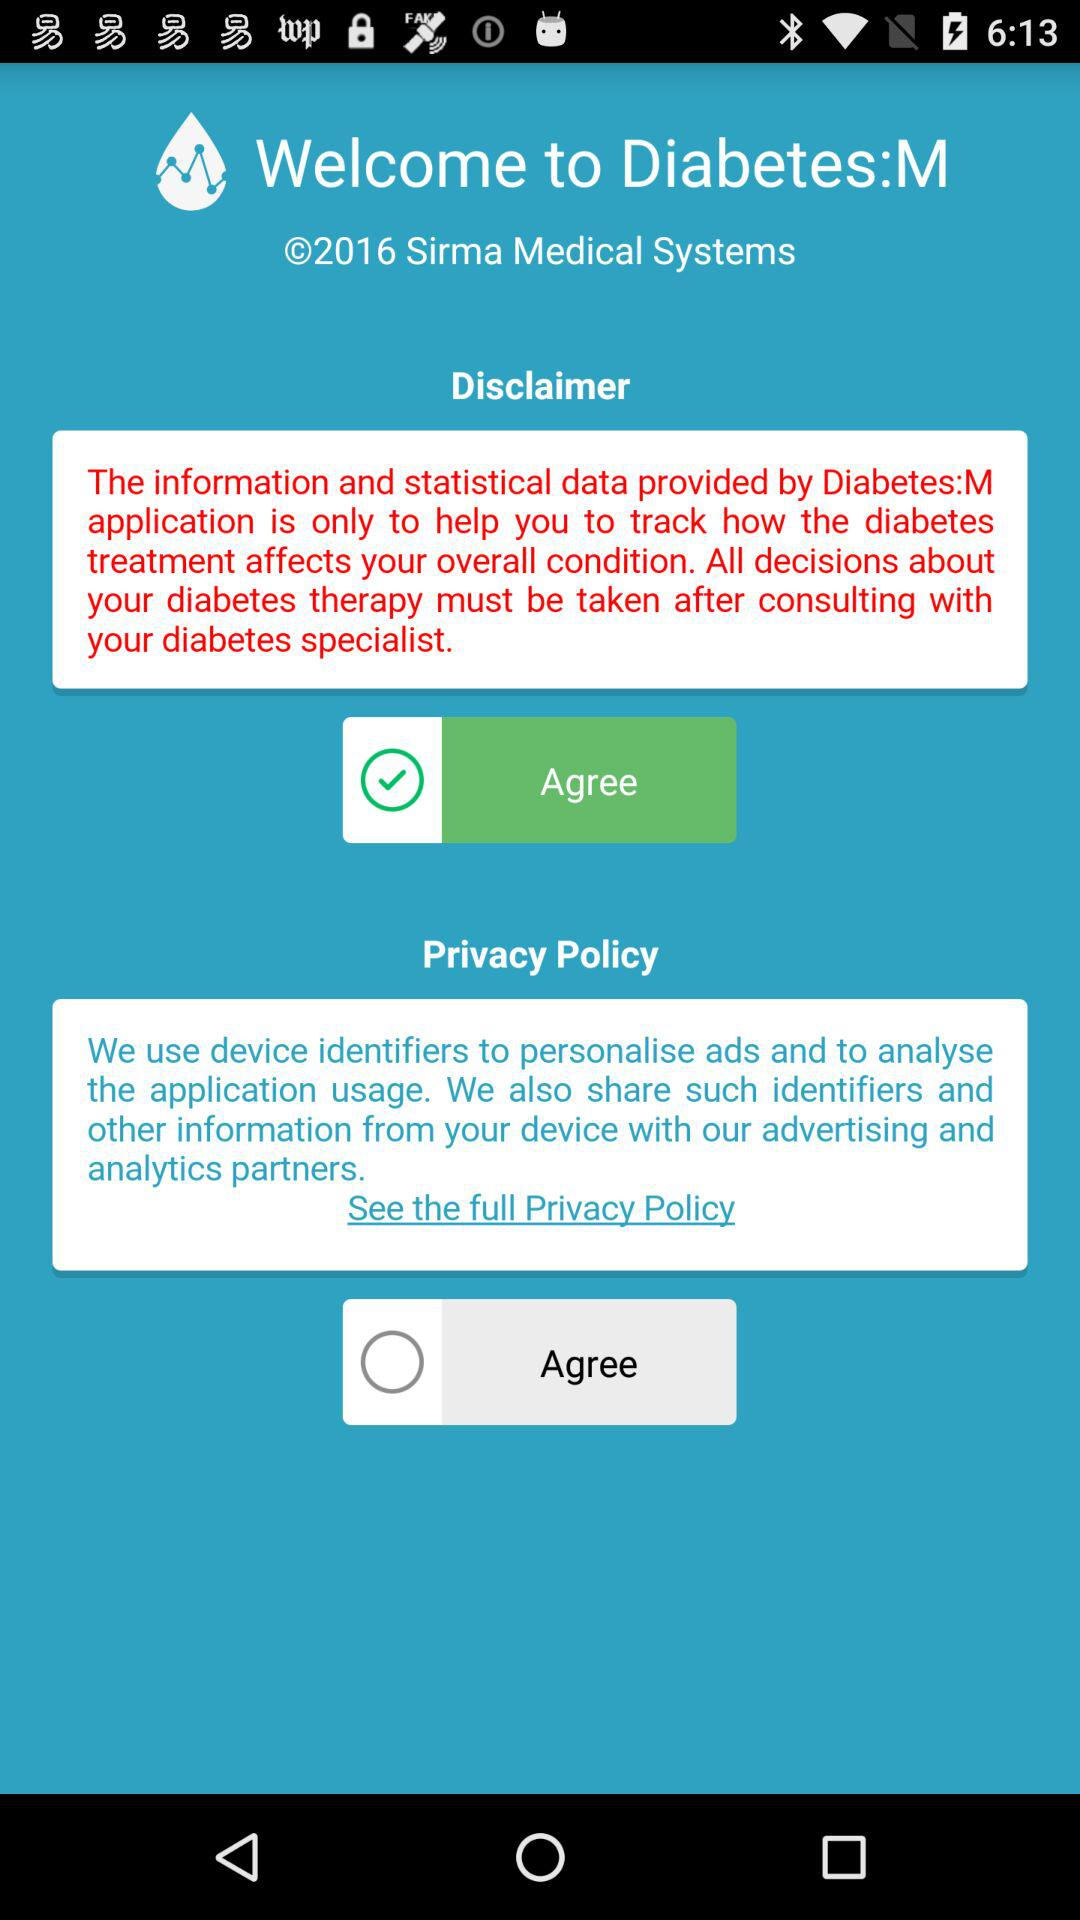What is the status of the "Disclaimer" agreement? The status is "Agree". 